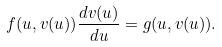<formula> <loc_0><loc_0><loc_500><loc_500>f ( u , v ( u ) ) \frac { d v ( u ) } { d u } = g ( u , v ( u ) ) .</formula> 